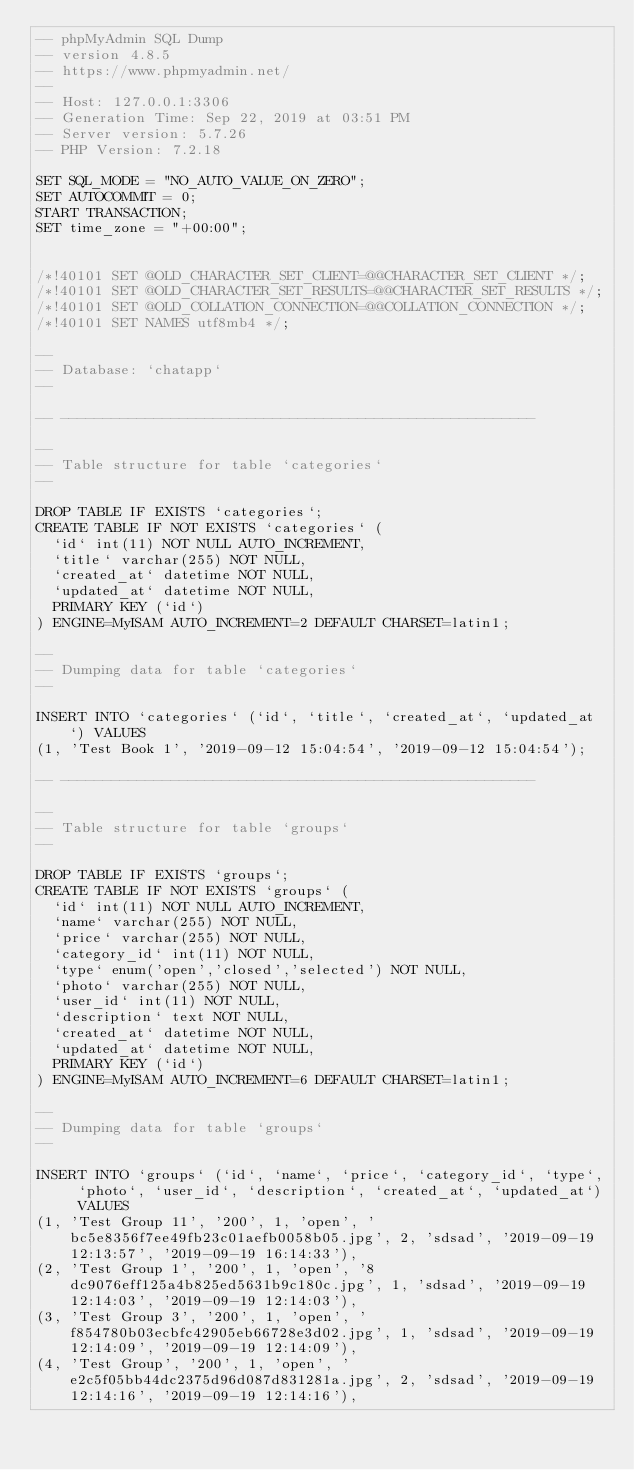<code> <loc_0><loc_0><loc_500><loc_500><_SQL_>-- phpMyAdmin SQL Dump
-- version 4.8.5
-- https://www.phpmyadmin.net/
--
-- Host: 127.0.0.1:3306
-- Generation Time: Sep 22, 2019 at 03:51 PM
-- Server version: 5.7.26
-- PHP Version: 7.2.18

SET SQL_MODE = "NO_AUTO_VALUE_ON_ZERO";
SET AUTOCOMMIT = 0;
START TRANSACTION;
SET time_zone = "+00:00";


/*!40101 SET @OLD_CHARACTER_SET_CLIENT=@@CHARACTER_SET_CLIENT */;
/*!40101 SET @OLD_CHARACTER_SET_RESULTS=@@CHARACTER_SET_RESULTS */;
/*!40101 SET @OLD_COLLATION_CONNECTION=@@COLLATION_CONNECTION */;
/*!40101 SET NAMES utf8mb4 */;

--
-- Database: `chatapp`
--

-- --------------------------------------------------------

--
-- Table structure for table `categories`
--

DROP TABLE IF EXISTS `categories`;
CREATE TABLE IF NOT EXISTS `categories` (
  `id` int(11) NOT NULL AUTO_INCREMENT,
  `title` varchar(255) NOT NULL,
  `created_at` datetime NOT NULL,
  `updated_at` datetime NOT NULL,
  PRIMARY KEY (`id`)
) ENGINE=MyISAM AUTO_INCREMENT=2 DEFAULT CHARSET=latin1;

--
-- Dumping data for table `categories`
--

INSERT INTO `categories` (`id`, `title`, `created_at`, `updated_at`) VALUES
(1, 'Test Book 1', '2019-09-12 15:04:54', '2019-09-12 15:04:54');

-- --------------------------------------------------------

--
-- Table structure for table `groups`
--

DROP TABLE IF EXISTS `groups`;
CREATE TABLE IF NOT EXISTS `groups` (
  `id` int(11) NOT NULL AUTO_INCREMENT,
  `name` varchar(255) NOT NULL,
  `price` varchar(255) NOT NULL,
  `category_id` int(11) NOT NULL,
  `type` enum('open','closed','selected') NOT NULL,
  `photo` varchar(255) NOT NULL,
  `user_id` int(11) NOT NULL,
  `description` text NOT NULL,
  `created_at` datetime NOT NULL,
  `updated_at` datetime NOT NULL,
  PRIMARY KEY (`id`)
) ENGINE=MyISAM AUTO_INCREMENT=6 DEFAULT CHARSET=latin1;

--
-- Dumping data for table `groups`
--

INSERT INTO `groups` (`id`, `name`, `price`, `category_id`, `type`, `photo`, `user_id`, `description`, `created_at`, `updated_at`) VALUES
(1, 'Test Group 11', '200', 1, 'open', 'bc5e8356f7ee49fb23c01aefb0058b05.jpg', 2, 'sdsad', '2019-09-19 12:13:57', '2019-09-19 16:14:33'),
(2, 'Test Group 1', '200', 1, 'open', '8dc9076eff125a4b825ed5631b9c180c.jpg', 1, 'sdsad', '2019-09-19 12:14:03', '2019-09-19 12:14:03'),
(3, 'Test Group 3', '200', 1, 'open', 'f854780b03ecbfc42905eb66728e3d02.jpg', 1, 'sdsad', '2019-09-19 12:14:09', '2019-09-19 12:14:09'),
(4, 'Test Group', '200', 1, 'open', 'e2c5f05bb44dc2375d96d087d831281a.jpg', 2, 'sdsad', '2019-09-19 12:14:16', '2019-09-19 12:14:16'),</code> 